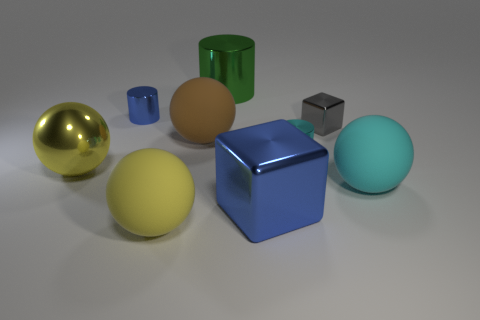Subtract 1 spheres. How many spheres are left? 3 Subtract all spheres. How many objects are left? 5 Subtract 0 purple cylinders. How many objects are left? 9 Subtract all yellow shiny cubes. Subtract all tiny gray metallic cubes. How many objects are left? 8 Add 2 blue cylinders. How many blue cylinders are left? 3 Add 1 yellow spheres. How many yellow spheres exist? 3 